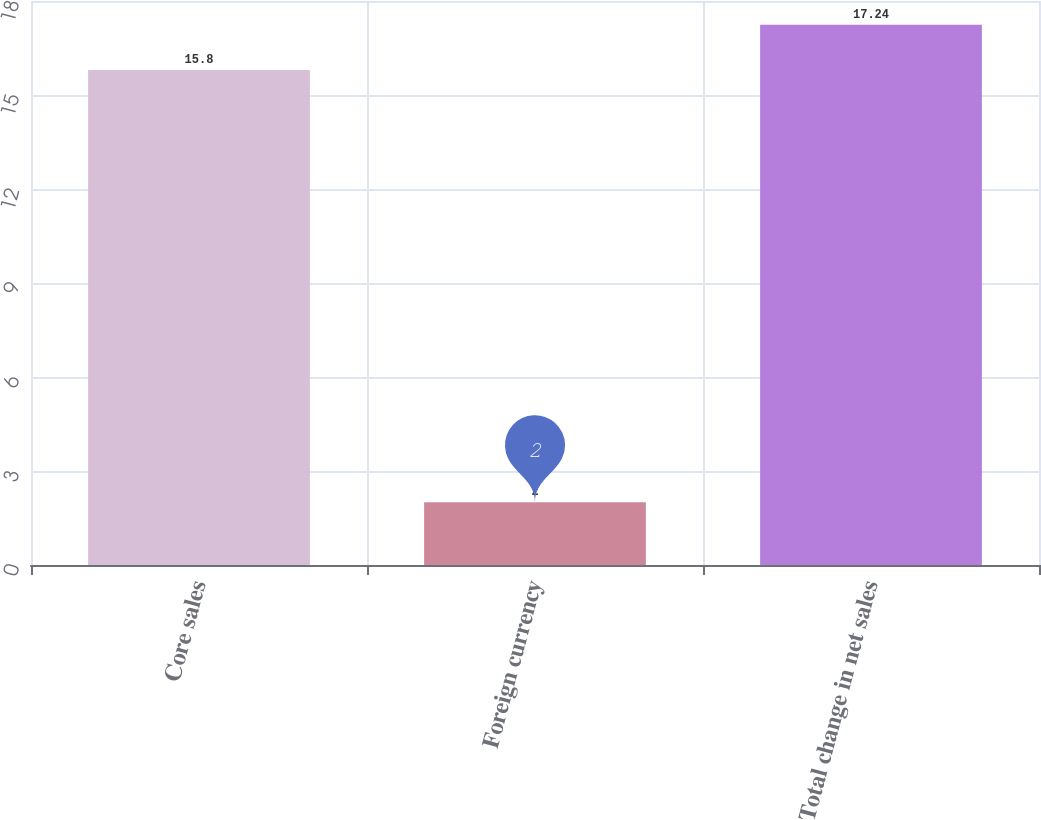<chart> <loc_0><loc_0><loc_500><loc_500><bar_chart><fcel>Core sales<fcel>Foreign currency<fcel>Total change in net sales<nl><fcel>15.8<fcel>2<fcel>17.24<nl></chart> 